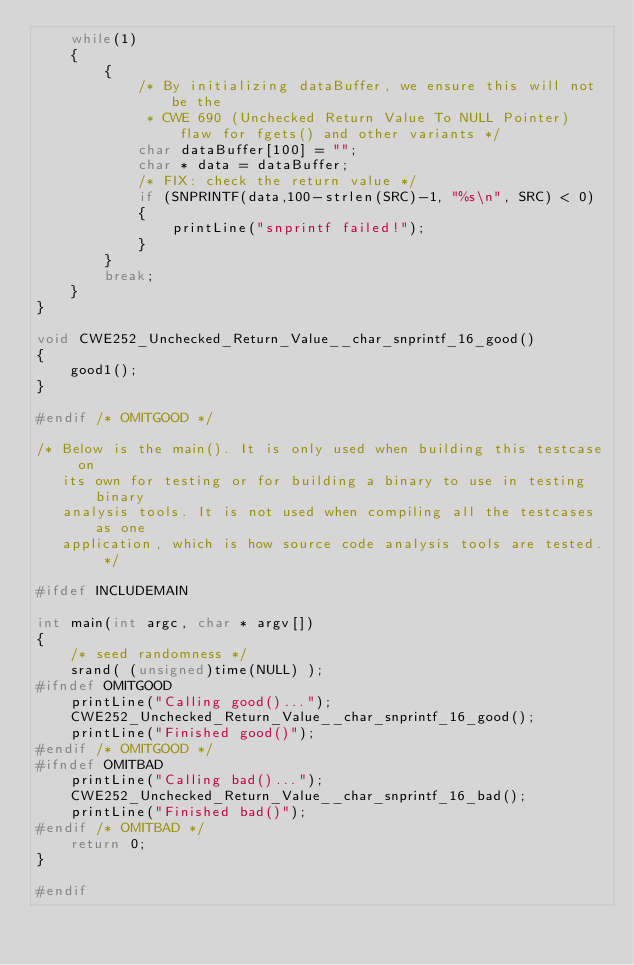<code> <loc_0><loc_0><loc_500><loc_500><_C_>    while(1)
    {
        {
            /* By initializing dataBuffer, we ensure this will not be the
             * CWE 690 (Unchecked Return Value To NULL Pointer) flaw for fgets() and other variants */
            char dataBuffer[100] = "";
            char * data = dataBuffer;
            /* FIX: check the return value */
            if (SNPRINTF(data,100-strlen(SRC)-1, "%s\n", SRC) < 0)
            {
                printLine("snprintf failed!");
            }
        }
        break;
    }
}

void CWE252_Unchecked_Return_Value__char_snprintf_16_good()
{
    good1();
}

#endif /* OMITGOOD */

/* Below is the main(). It is only used when building this testcase on
   its own for testing or for building a binary to use in testing binary
   analysis tools. It is not used when compiling all the testcases as one
   application, which is how source code analysis tools are tested. */

#ifdef INCLUDEMAIN

int main(int argc, char * argv[])
{
    /* seed randomness */
    srand( (unsigned)time(NULL) );
#ifndef OMITGOOD
    printLine("Calling good()...");
    CWE252_Unchecked_Return_Value__char_snprintf_16_good();
    printLine("Finished good()");
#endif /* OMITGOOD */
#ifndef OMITBAD
    printLine("Calling bad()...");
    CWE252_Unchecked_Return_Value__char_snprintf_16_bad();
    printLine("Finished bad()");
#endif /* OMITBAD */
    return 0;
}

#endif
</code> 